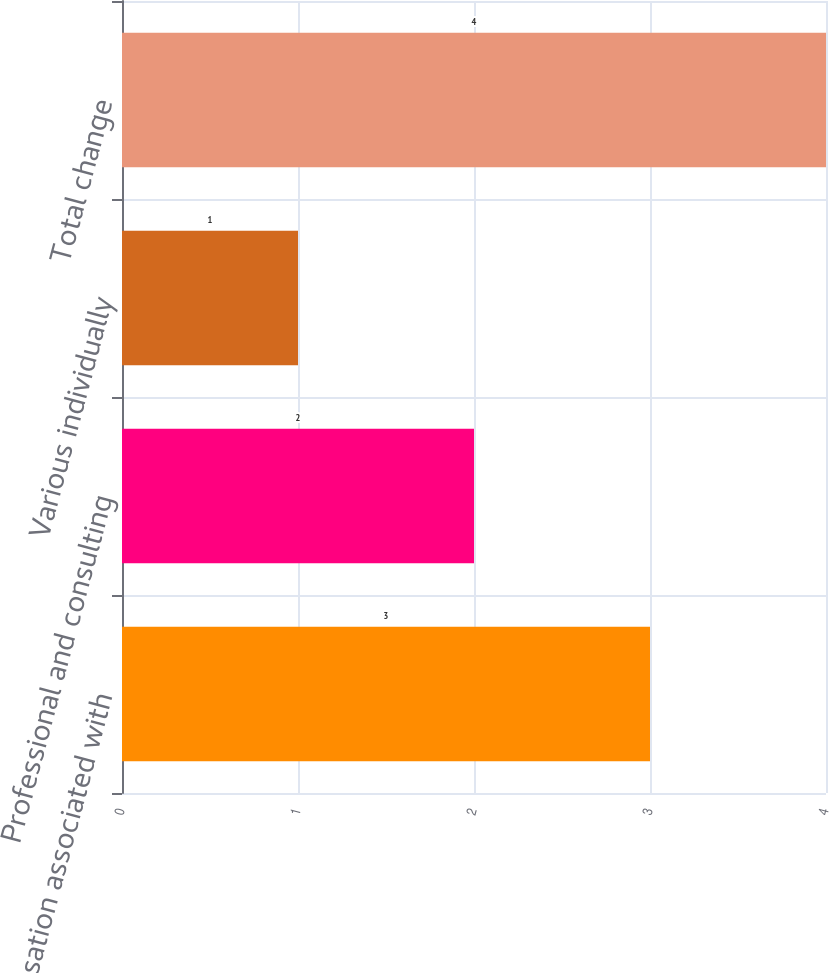Convert chart. <chart><loc_0><loc_0><loc_500><loc_500><bar_chart><fcel>Compensation associated with<fcel>Professional and consulting<fcel>Various individually<fcel>Total change<nl><fcel>3<fcel>2<fcel>1<fcel>4<nl></chart> 